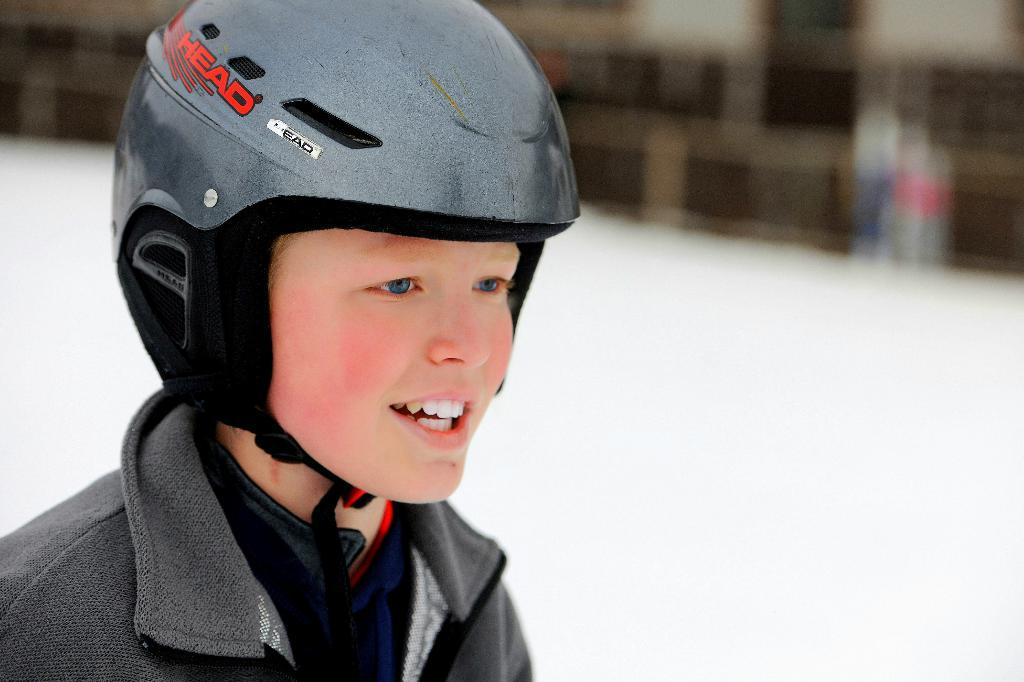Who is the main subject in the image? There is a boy in the image. What is the boy wearing on his head? The boy is wearing a helmet. Can you describe the background of the image? The background of the image appears blurry. What type of tub can be seen in the image? There is no tub present in the image. Can you identify any veins in the boy's body in the image? The image does not show any veins in the boy's body; it only shows him wearing a helmet. 